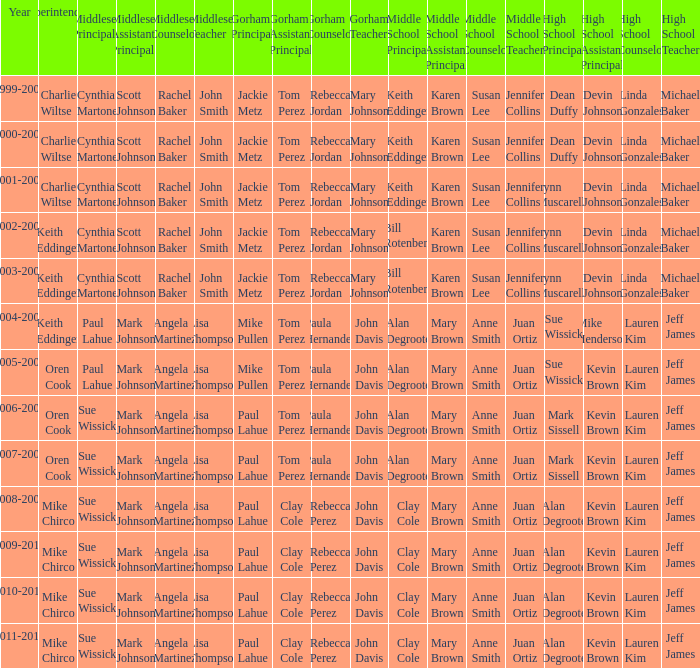How many high school principals were there in 2000-2001? Dean Duffy. 